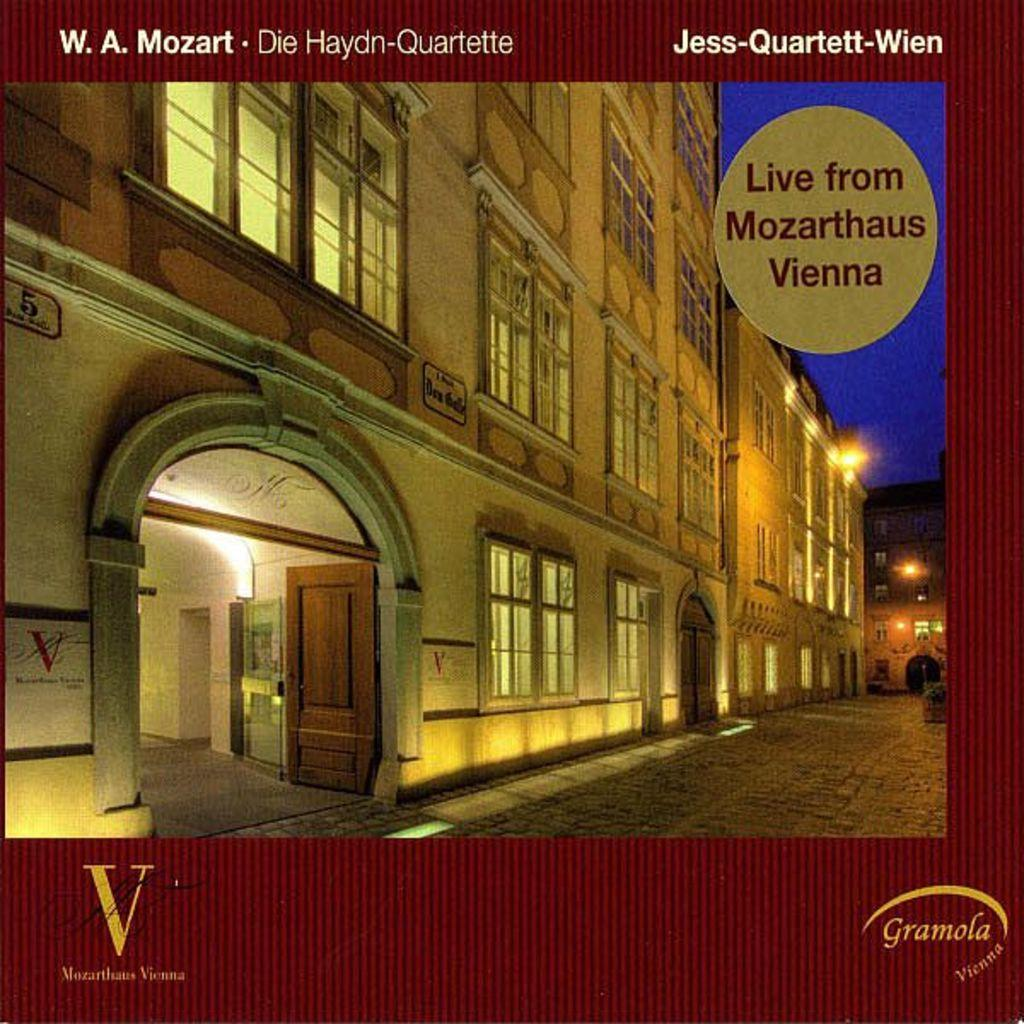What is featured in the image? There is a poster in the image. What does the poster depict? The poster depicts the ground, a building, and the sky. Are there any specific features of the building on the poster? Yes, there are windows and lights on the building. Is there any text on the poster? Yes, there is text written on the poster. What type of oatmeal is being served in the image? There is no oatmeal present in the image; it only features a poster with a building, ground, and sky. How many bulbs are visible on the poster? There is no mention of bulbs in the image or the provided facts; the poster only depicts a building with lights, windows, and text. 